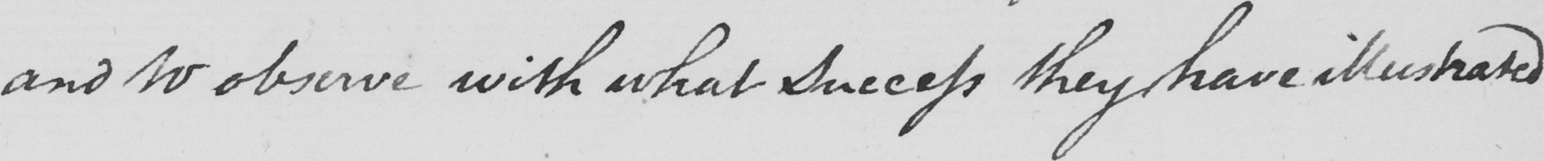Can you tell me what this handwritten text says? and to observe with what success they have illustrated 